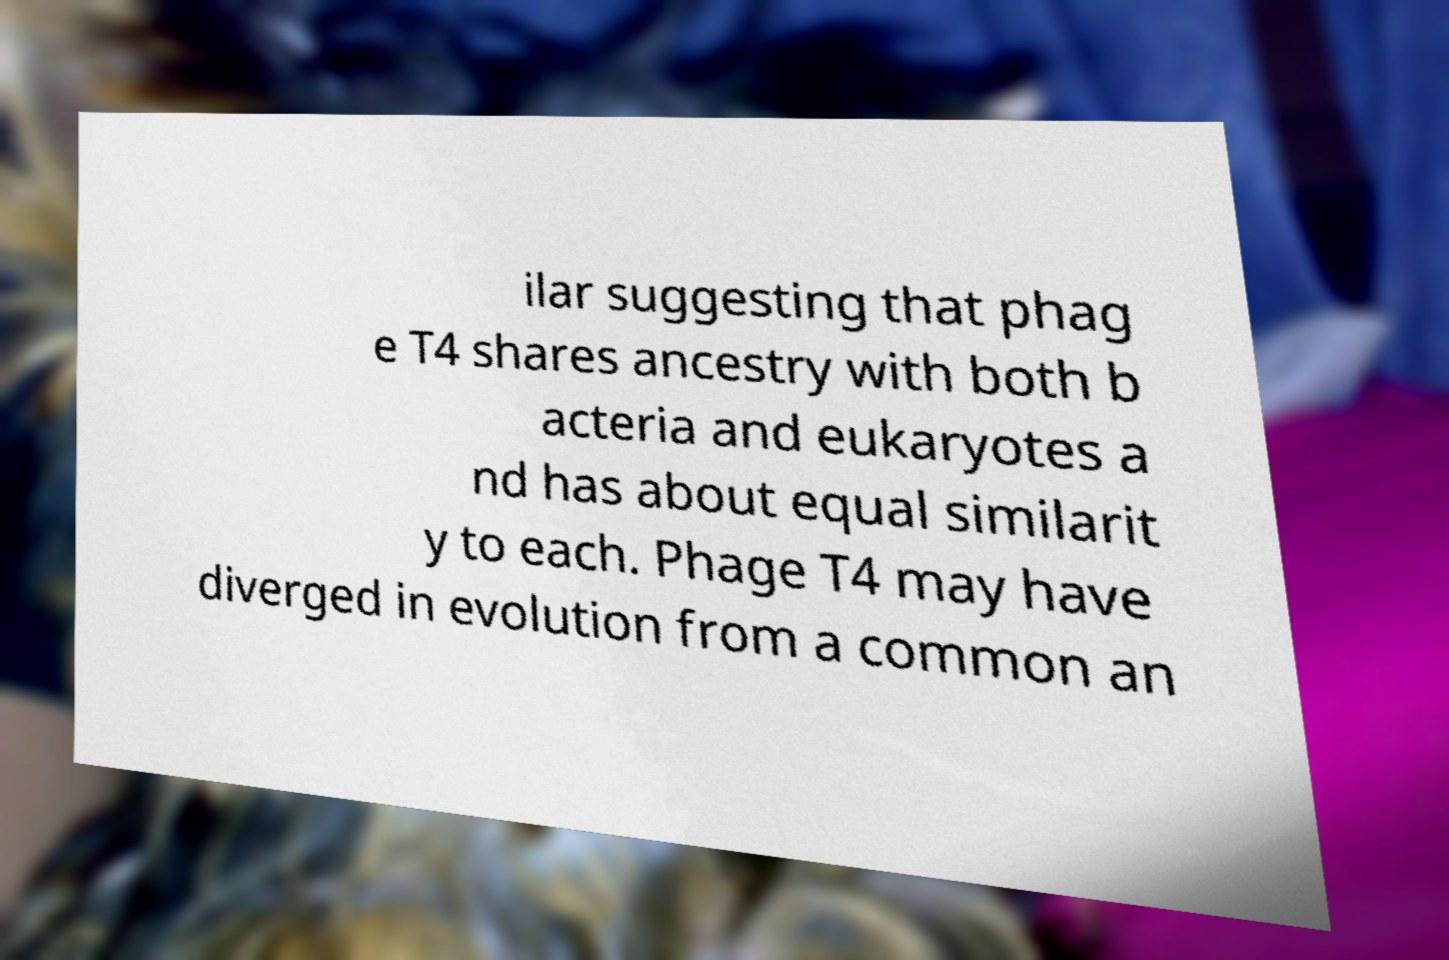Can you read and provide the text displayed in the image?This photo seems to have some interesting text. Can you extract and type it out for me? ilar suggesting that phag e T4 shares ancestry with both b acteria and eukaryotes a nd has about equal similarit y to each. Phage T4 may have diverged in evolution from a common an 